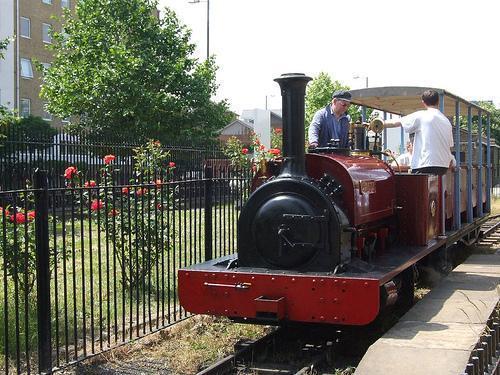How many people are in the image?
Give a very brief answer. 2. 